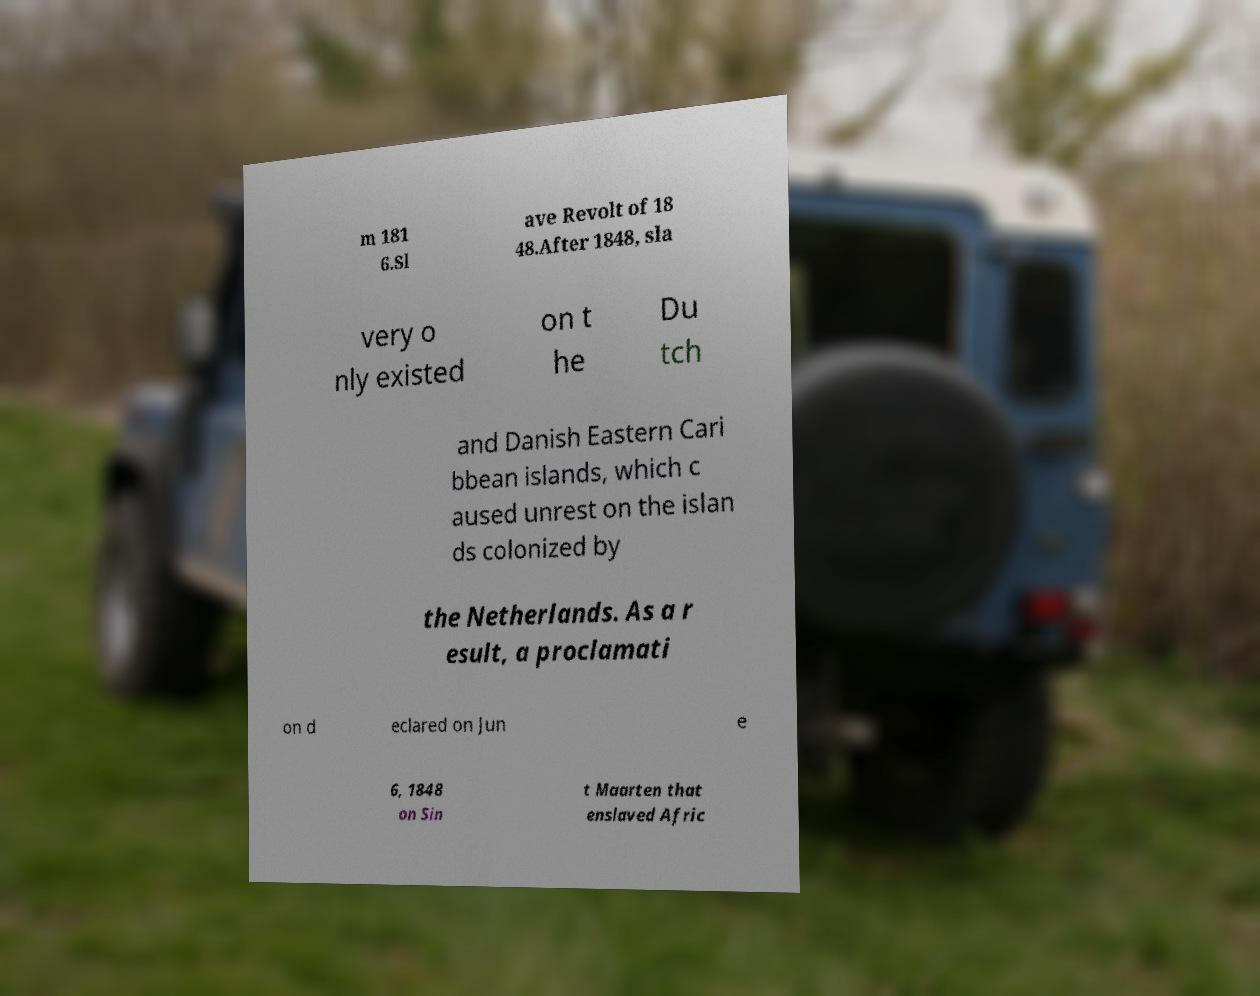I need the written content from this picture converted into text. Can you do that? m 181 6.Sl ave Revolt of 18 48.After 1848, sla very o nly existed on t he Du tch and Danish Eastern Cari bbean islands, which c aused unrest on the islan ds colonized by the Netherlands. As a r esult, a proclamati on d eclared on Jun e 6, 1848 on Sin t Maarten that enslaved Afric 